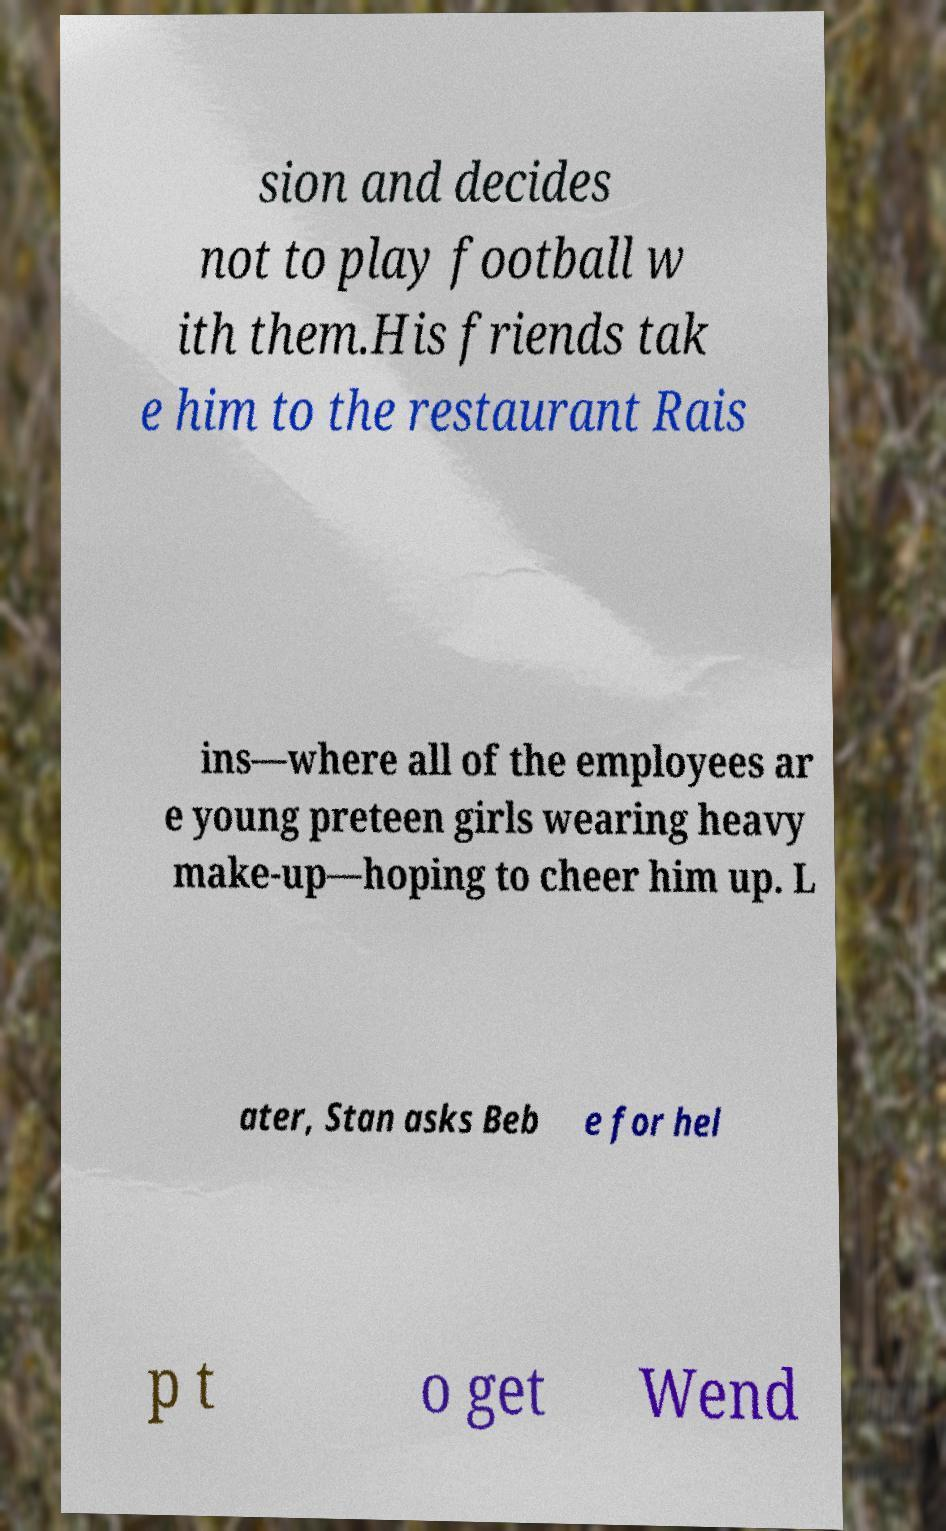There's text embedded in this image that I need extracted. Can you transcribe it verbatim? sion and decides not to play football w ith them.His friends tak e him to the restaurant Rais ins—where all of the employees ar e young preteen girls wearing heavy make-up—hoping to cheer him up. L ater, Stan asks Beb e for hel p t o get Wend 